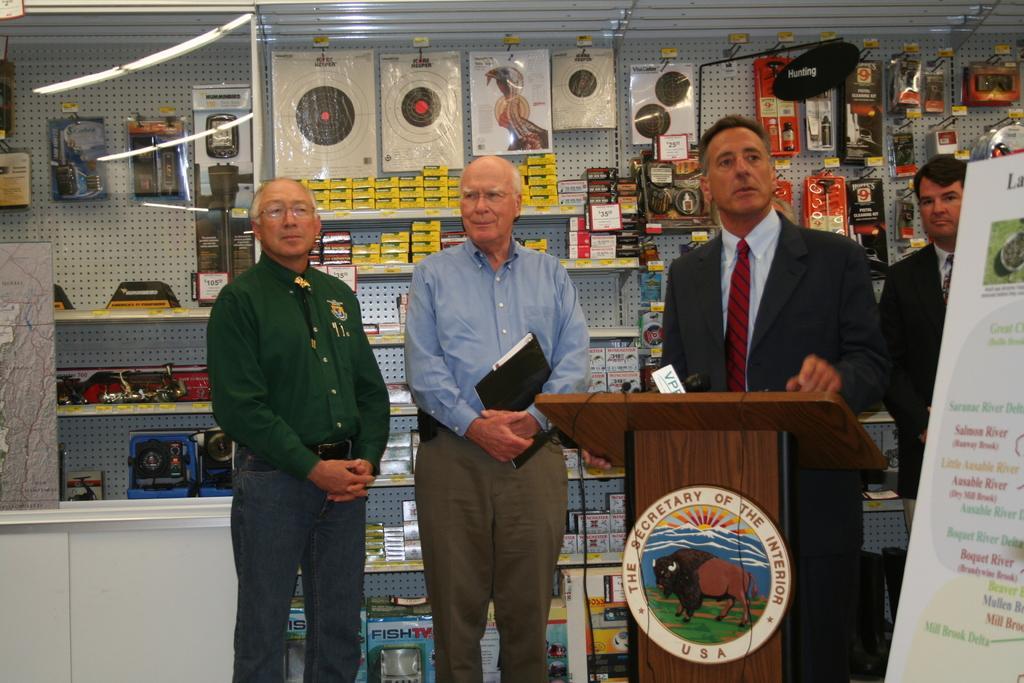Describe this image in one or two sentences. In this picture we can see four men standing, podium with a mic on it, poster and in the background we can see packets, boxes and some objects. 